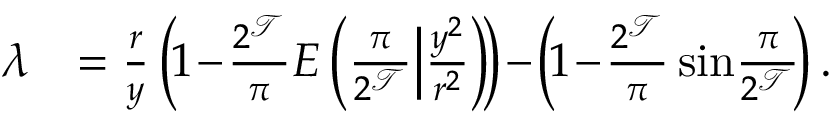Convert formula to latex. <formula><loc_0><loc_0><loc_500><loc_500>\begin{array} { r l } { \lambda } & { = \frac { r } { y } \left ( \, 1 \, - \, \frac { 2 ^ { \mathcal { T } } } { \pi } E \left ( \frac { \pi } { 2 ^ { \mathcal { T } } } \Big | \frac { y ^ { 2 } } { r ^ { 2 } } \right ) \, \right ) \, - \, \left ( \, 1 \, - \, \frac { 2 ^ { \mathcal { T } } } { \pi } \sin \, \frac { \pi } { 2 ^ { \mathcal { T } } } \, \right ) . } \end{array}</formula> 